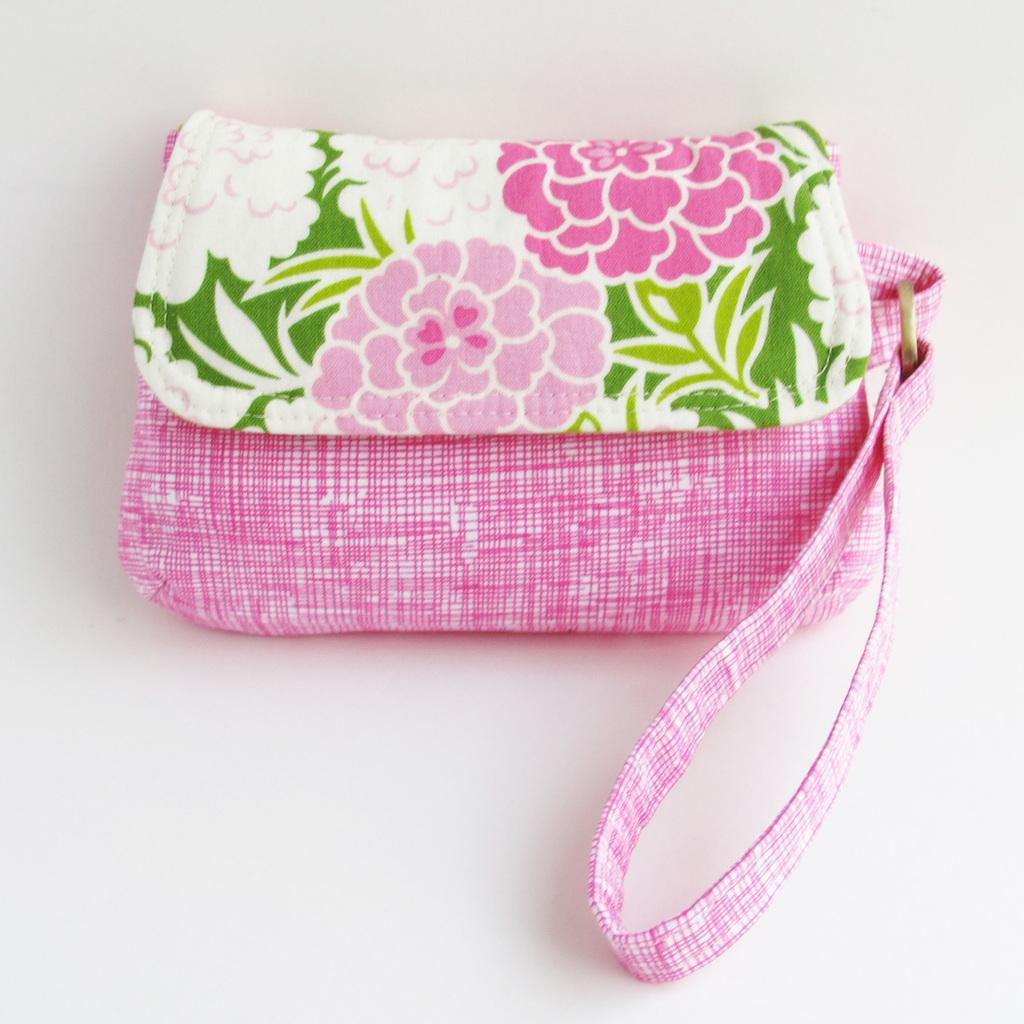What object can be seen in the picture? There is a handbag in the picture. What design is featured on the handbag? The handbag has flowers printed on it. Is there any accessory or feature related to the handbag? Yes, there is a holder associated with the handbag. How many pears are visible inside the handbag in the image? There are no pears present in the image, as it features a handbag with flowers printed on it. 